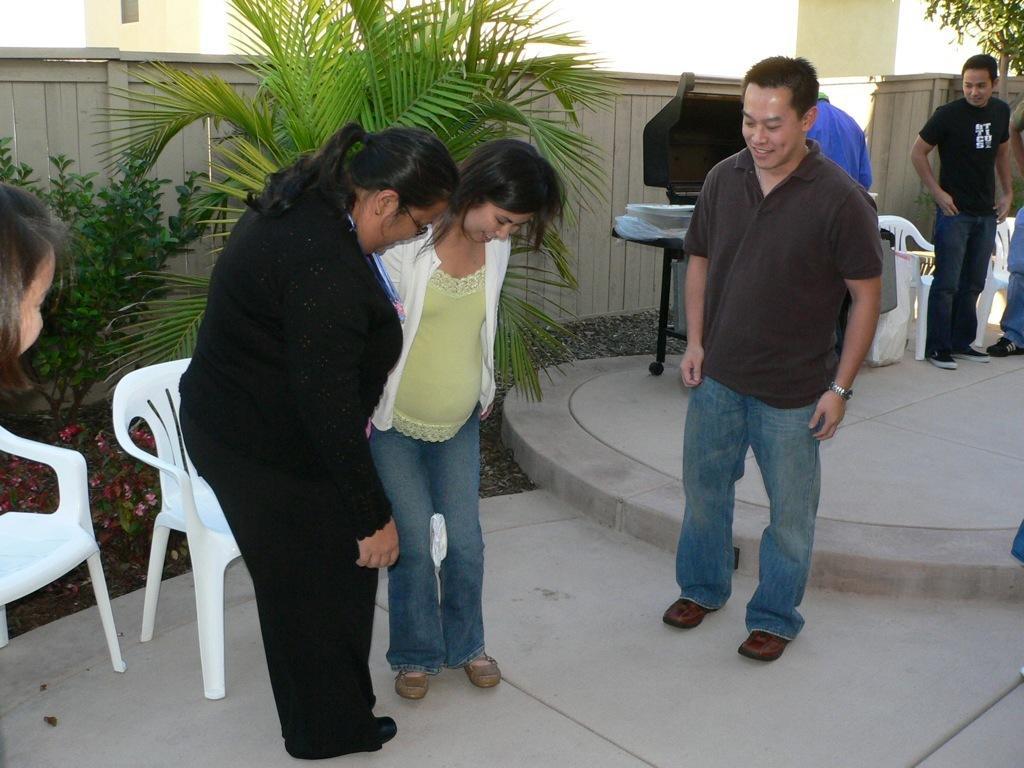Can you describe this image briefly? In this image we can see men and women standing on the floor. In the background there are wooden fence, buildings, shrubs, plants and chairs. 